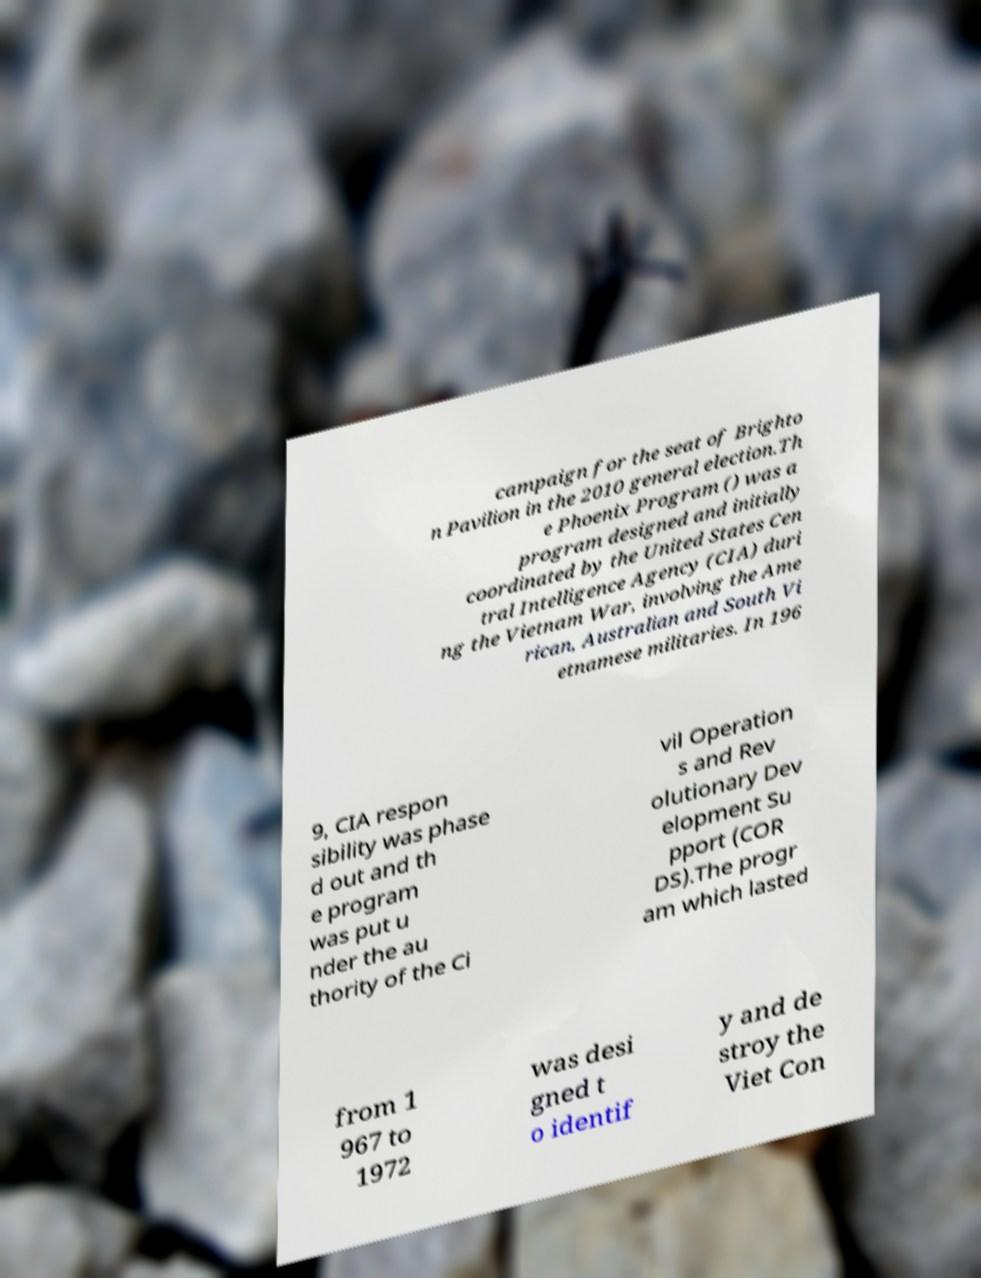For documentation purposes, I need the text within this image transcribed. Could you provide that? campaign for the seat of Brighto n Pavilion in the 2010 general election.Th e Phoenix Program () was a program designed and initially coordinated by the United States Cen tral Intelligence Agency (CIA) duri ng the Vietnam War, involving the Ame rican, Australian and South Vi etnamese militaries. In 196 9, CIA respon sibility was phase d out and th e program was put u nder the au thority of the Ci vil Operation s and Rev olutionary Dev elopment Su pport (COR DS).The progr am which lasted from 1 967 to 1972 was desi gned t o identif y and de stroy the Viet Con 